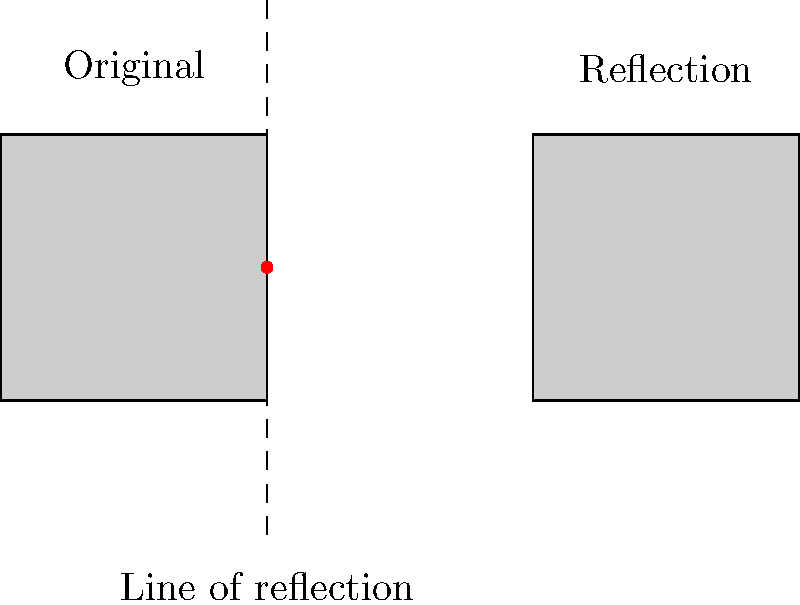Your friend shows you a new skateboard graphic design. The design is reflected across a vertical line to create a symmetrical pattern. If the original design's top-right corner is at (0,1) and bottom-right corner is at (0,-1), where would the top-right corner of the reflected design be located? To solve this problem, we need to understand how reflection across a vertical line works:

1. The vertical line of reflection acts like a mirror.
2. Each point of the original shape is reflected to an equal distance on the opposite side of the line.
3. The y-coordinates remain the same, while the x-coordinates change.

Given:
- The original design's top-right corner is at (0,1).
- The line of reflection is vertical and passes through x = 0.

Steps:
1. Identify the x-coordinate of the point: x = 0
2. The distance from this point to the line of reflection is 0.
3. The reflected point will be the same distance (0) from the line on the opposite side.
4. The y-coordinate remains unchanged: y = 1

Therefore, the reflected top-right corner will be at (0,1), which is the same as the original point.
Answer: (0,1) 